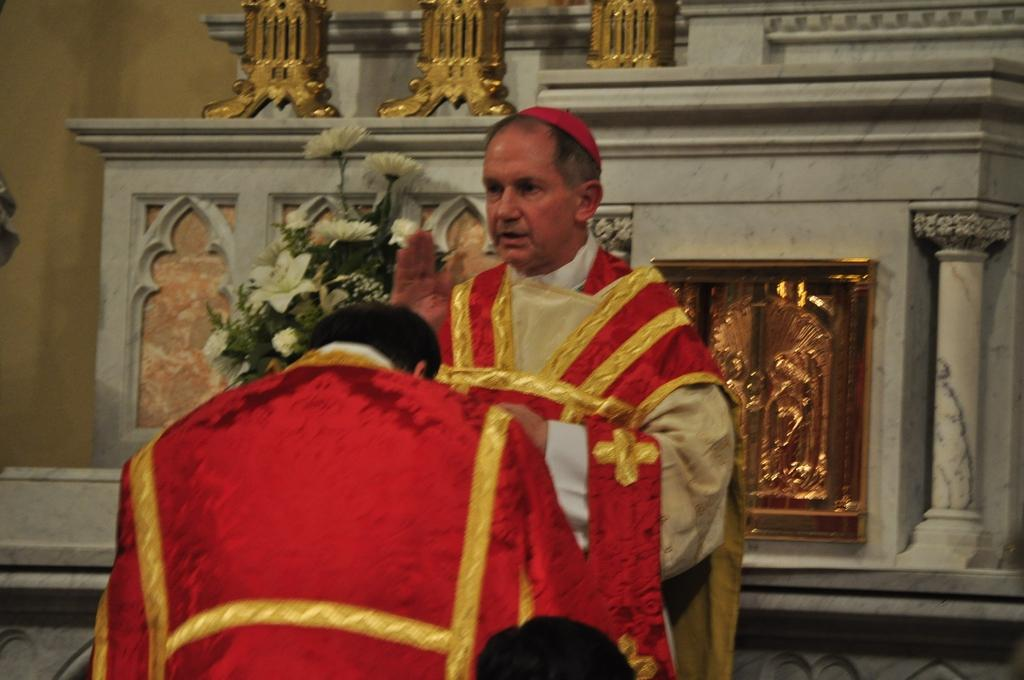Who is the main subject in the image? There is a priest in the image. What is the priest wearing? The priest is wearing a red dress. Where is the priest positioned in the image? The priest is standing in the front of the image. Can you describe the person in front of the priest? There is a person in front of the priest, but no specific details about the person are provided. What can be seen on the wall in the image? There is a wall in the image, and a flower bouquet is on a shelf on the wall. What type of organization is the priest affiliated with in the image? There is no information provided about the priest's affiliation or organization in the image. Can you tell me how many potatoes are present in the image? There are no potatoes present in the image. 